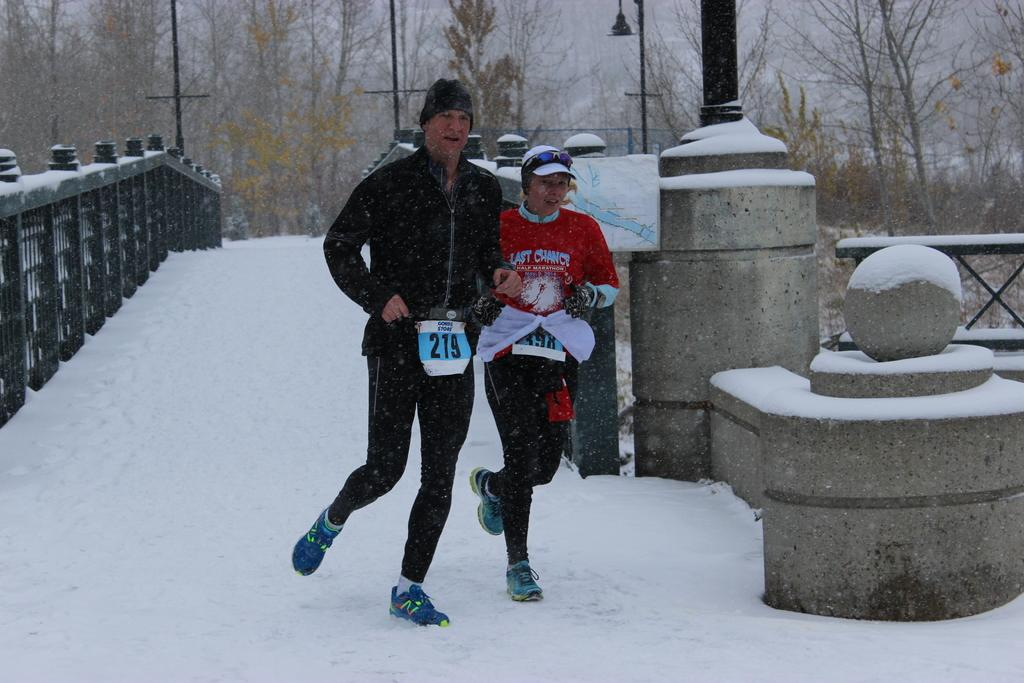<image>
Render a clear and concise summary of the photo. A man and a woman are running down a snowy bridge with the man having the number 219 hanging off him. 